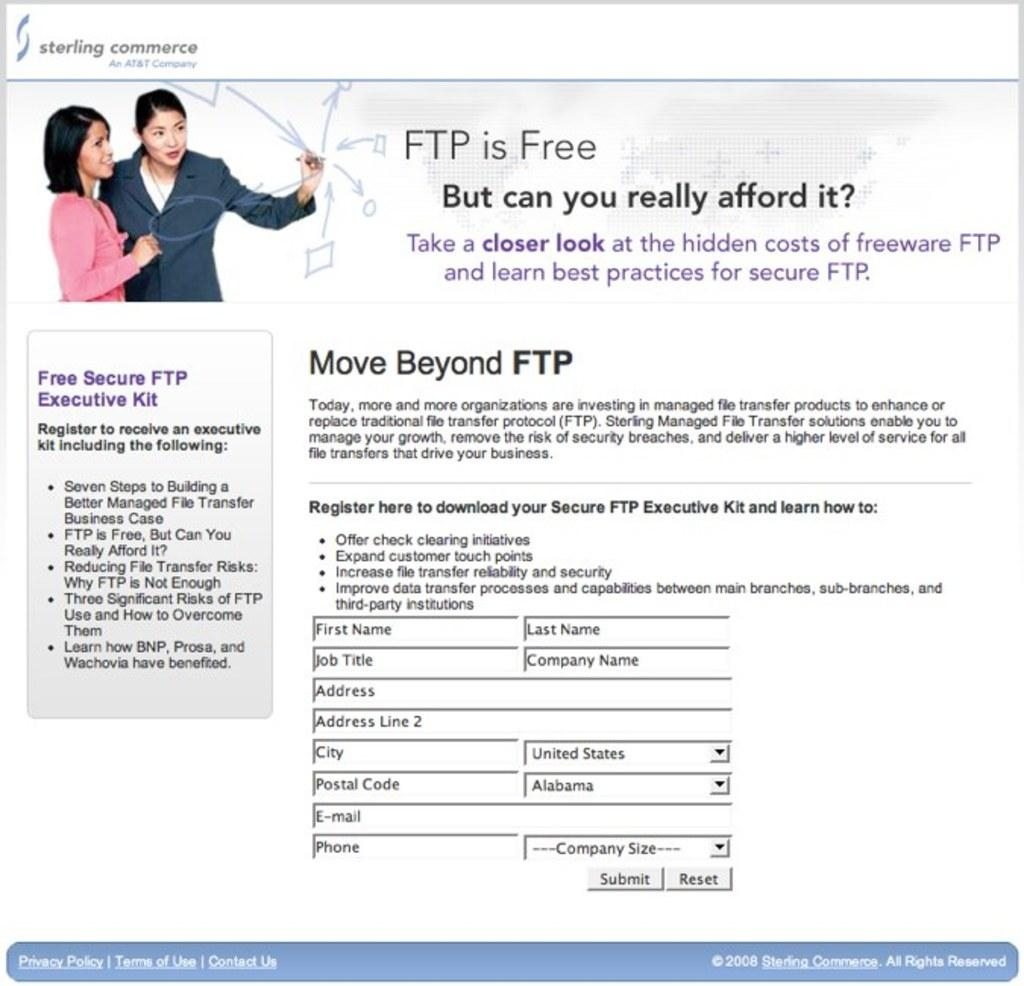How many women are in the image? There are two women in the image. Where are the women located in the image? The women are in the left top corner of the image. What can be found beside and below the women? There is something written beside and below the women. What type of bed is visible in the image? There is no bed present in the image. Can you describe the contents of the basket in the image? There is no basket present in the image. Is there any advertisement visible in the image? The provided facts do not mention any advertisement in the image. 